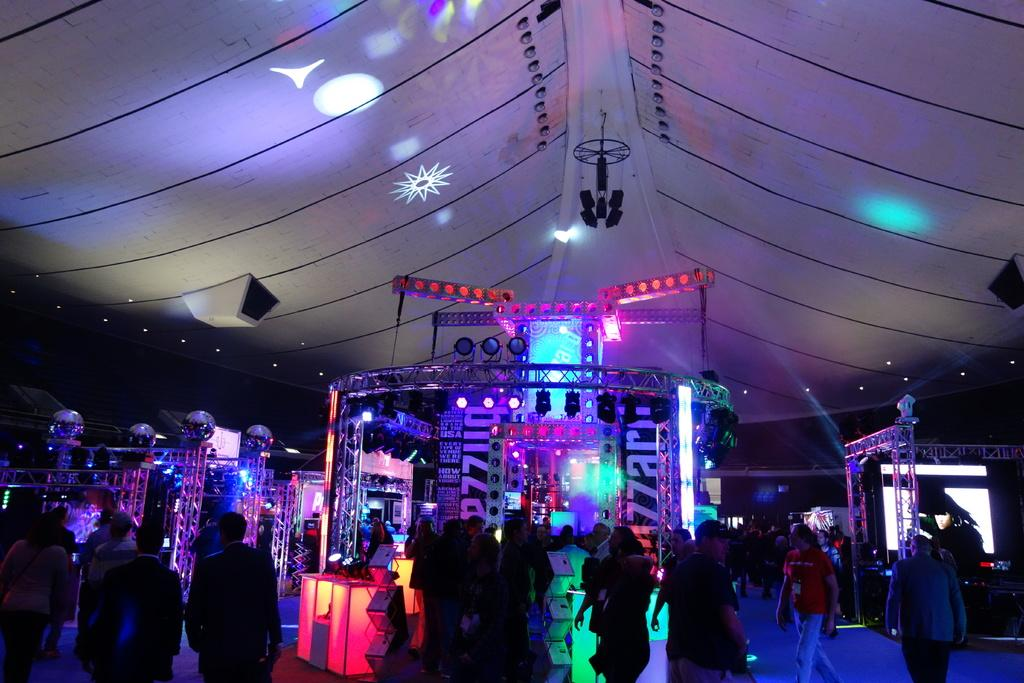Where is the image taken? The image is taken inside a tent. What can be seen in the center of the image? There are stalls in the center of the image. What are the people in the image doing? People are walking at the bottom of the image. What can be seen providing illumination in the image? There are lights visible in the image. What type of force is being applied to the woman in the image? There is no woman present in the image, so no force can be applied to her. 